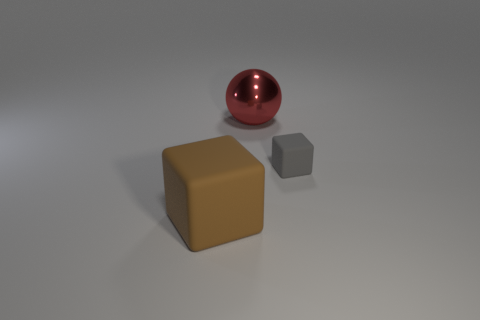Add 2 big red metallic objects. How many objects exist? 5 Subtract all cubes. How many objects are left? 1 Add 1 gray blocks. How many gray blocks exist? 2 Subtract 0 brown spheres. How many objects are left? 3 Subtract all brown rubber cubes. Subtract all tiny matte balls. How many objects are left? 2 Add 2 cubes. How many cubes are left? 4 